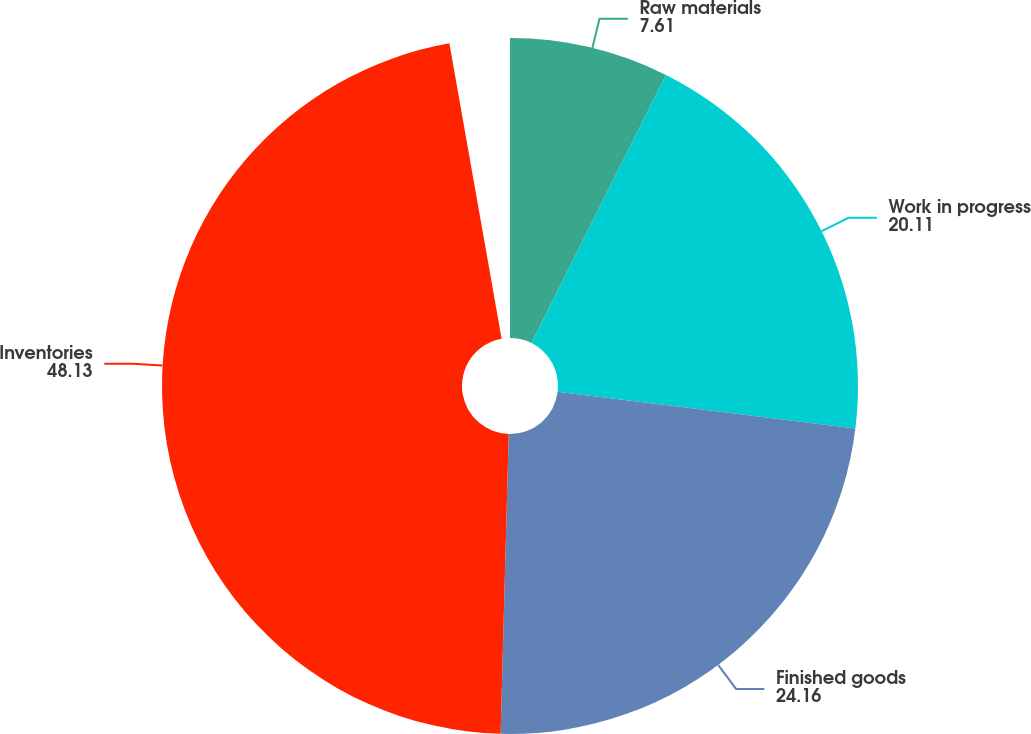Convert chart to OTSL. <chart><loc_0><loc_0><loc_500><loc_500><pie_chart><fcel>Raw materials<fcel>Work in progress<fcel>Finished goods<fcel>Inventories<nl><fcel>7.61%<fcel>20.11%<fcel>24.16%<fcel>48.13%<nl></chart> 